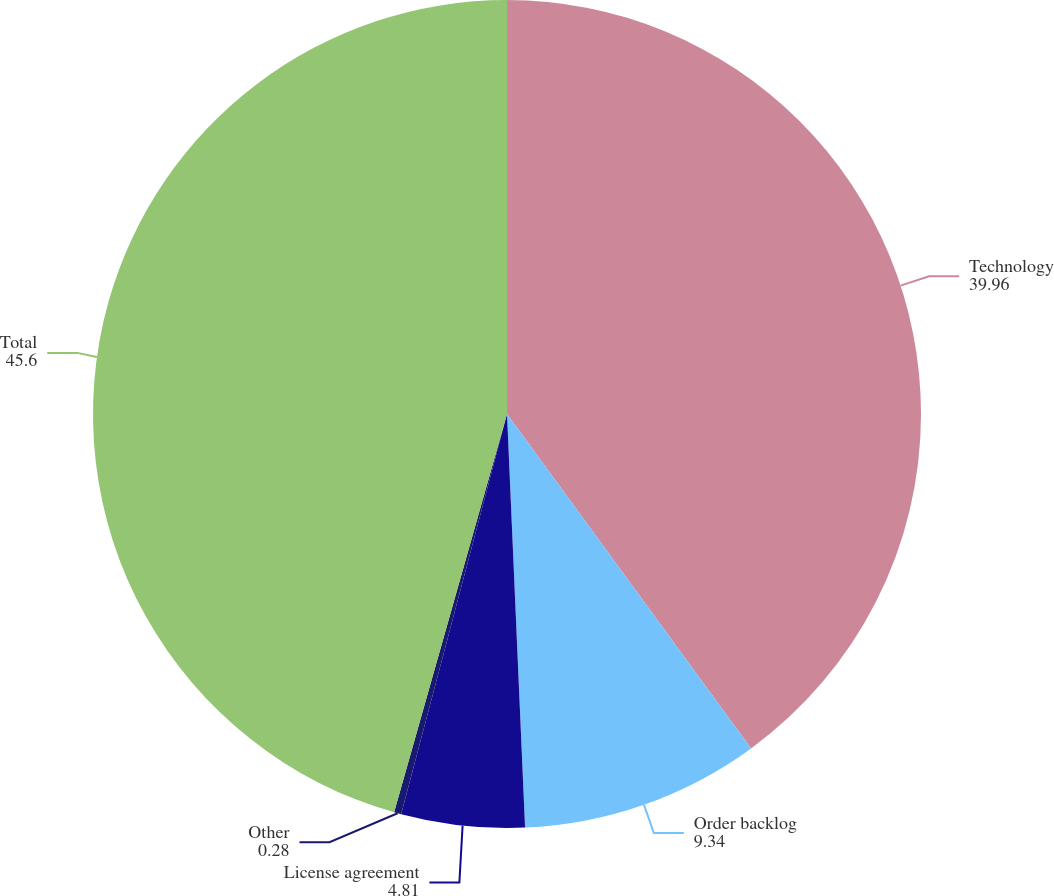<chart> <loc_0><loc_0><loc_500><loc_500><pie_chart><fcel>Technology<fcel>Order backlog<fcel>License agreement<fcel>Other<fcel>Total<nl><fcel>39.96%<fcel>9.34%<fcel>4.81%<fcel>0.28%<fcel>45.6%<nl></chart> 